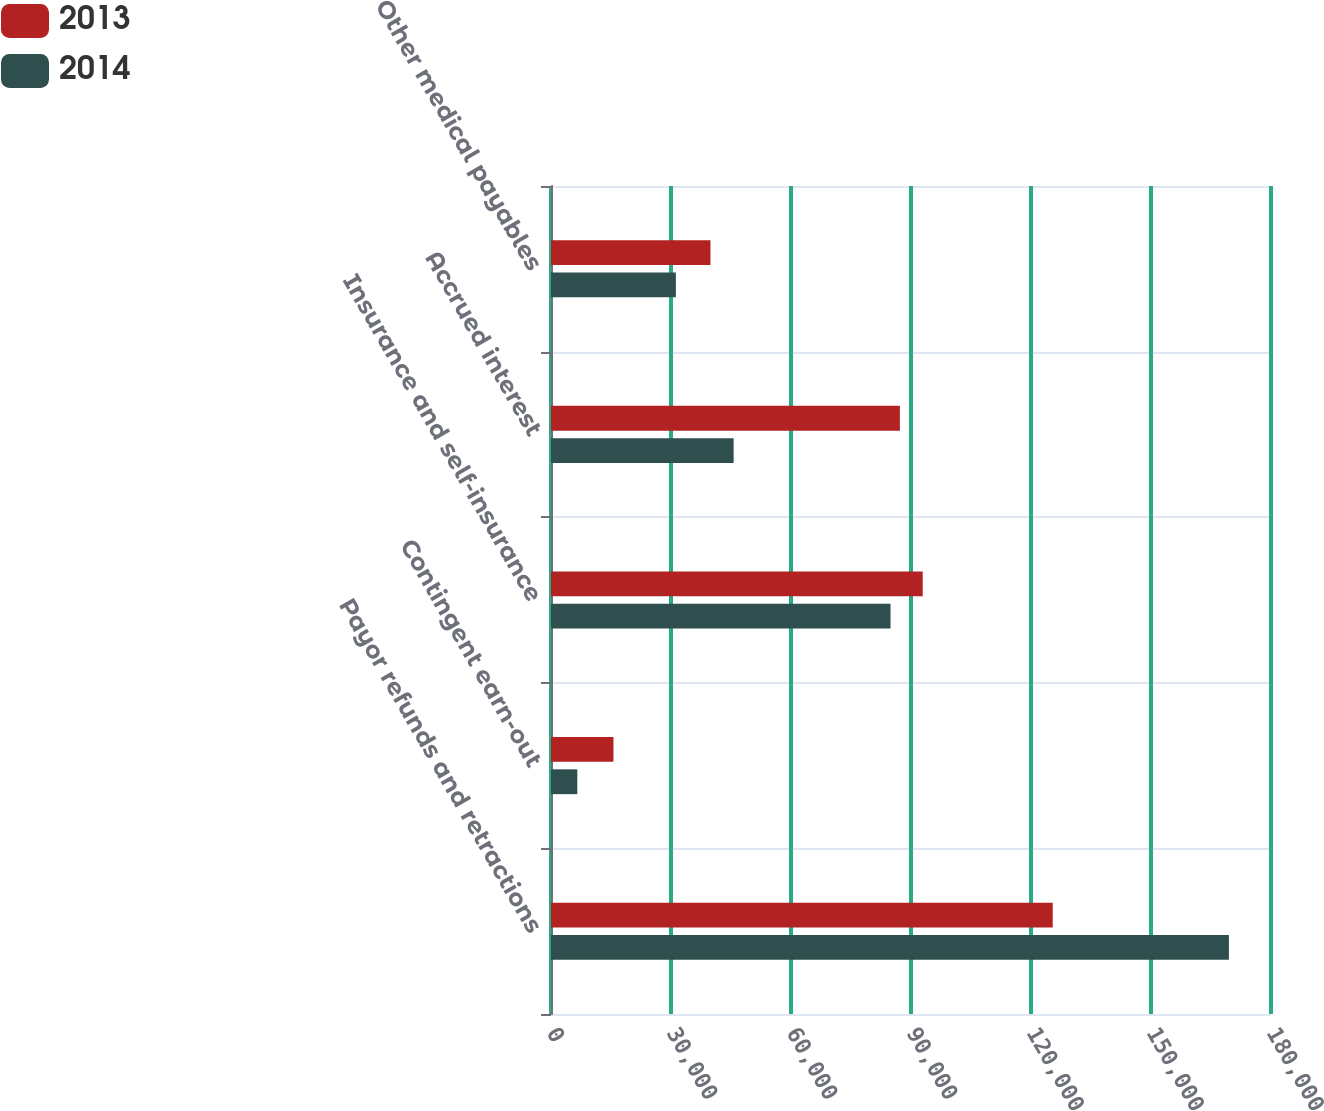Convert chart to OTSL. <chart><loc_0><loc_0><loc_500><loc_500><stacked_bar_chart><ecel><fcel>Payor refunds and retractions<fcel>Contingent earn-out<fcel>Insurance and self-insurance<fcel>Accrued interest<fcel>Other medical payables<nl><fcel>2013<fcel>125435<fcel>15614<fcel>92928<fcel>87224<fcel>39867<nl><fcel>2014<fcel>169480<fcel>6577<fcel>84882<fcel>45662<fcel>31219<nl></chart> 